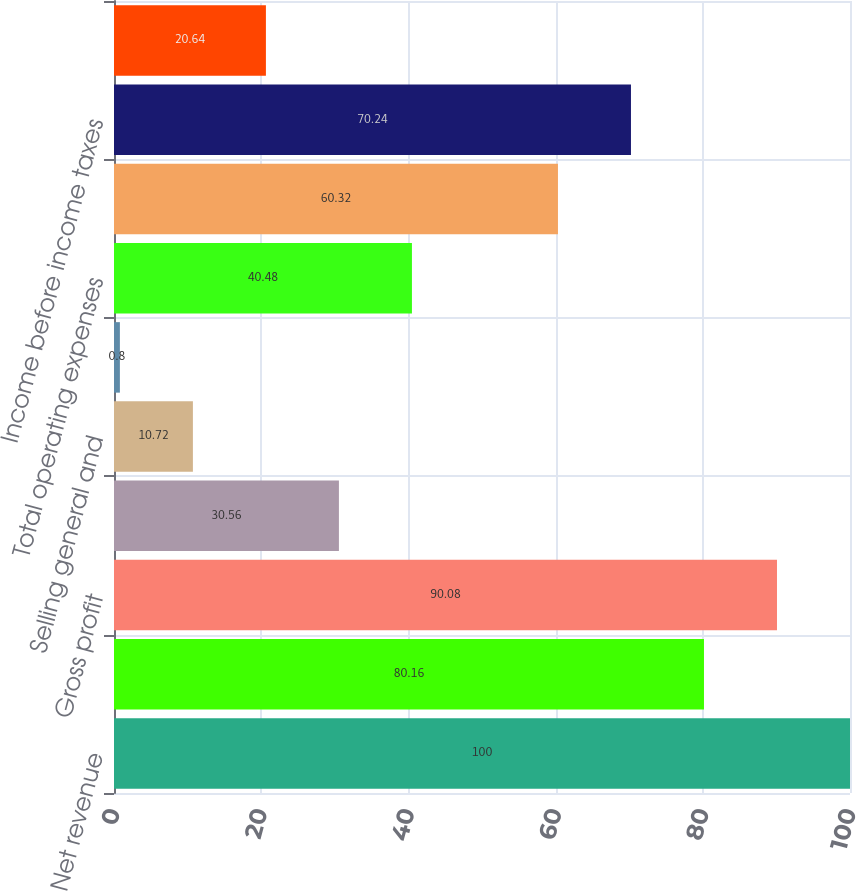<chart> <loc_0><loc_0><loc_500><loc_500><bar_chart><fcel>Net revenue<fcel>Cost of goods sold<fcel>Gross profit<fcel>Research and development<fcel>Selling general and<fcel>Amortization of intangibles<fcel>Total operating expenses<fcel>Operating income<fcel>Income before income taxes<fcel>Provision for income taxes<nl><fcel>100<fcel>80.16<fcel>90.08<fcel>30.56<fcel>10.72<fcel>0.8<fcel>40.48<fcel>60.32<fcel>70.24<fcel>20.64<nl></chart> 